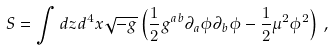Convert formula to latex. <formula><loc_0><loc_0><loc_500><loc_500>S = \int d z d ^ { 4 } x \sqrt { - g } \left ( { \frac { 1 } { 2 } } g ^ { a b } \partial _ { a } \phi \partial _ { b } \phi - { \frac { 1 } { 2 } } \mu ^ { 2 } \phi ^ { 2 } \right ) \, ,</formula> 